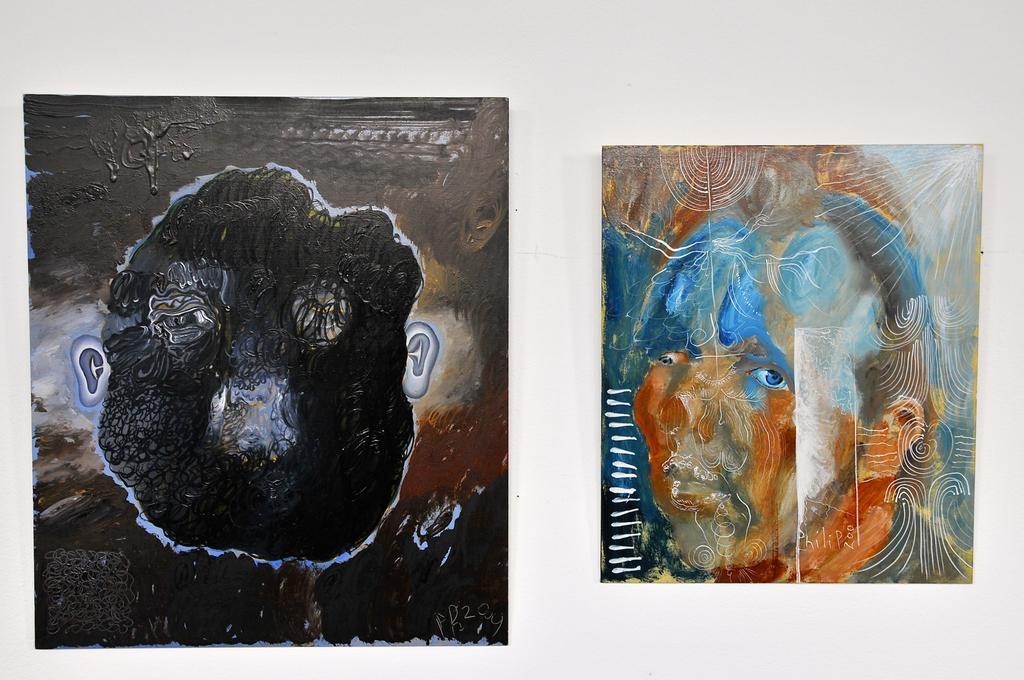Please provide a concise description of this image. In the picture we can see two paintings, one is brown in color with a human face and one is blue and orange in color with human face. 